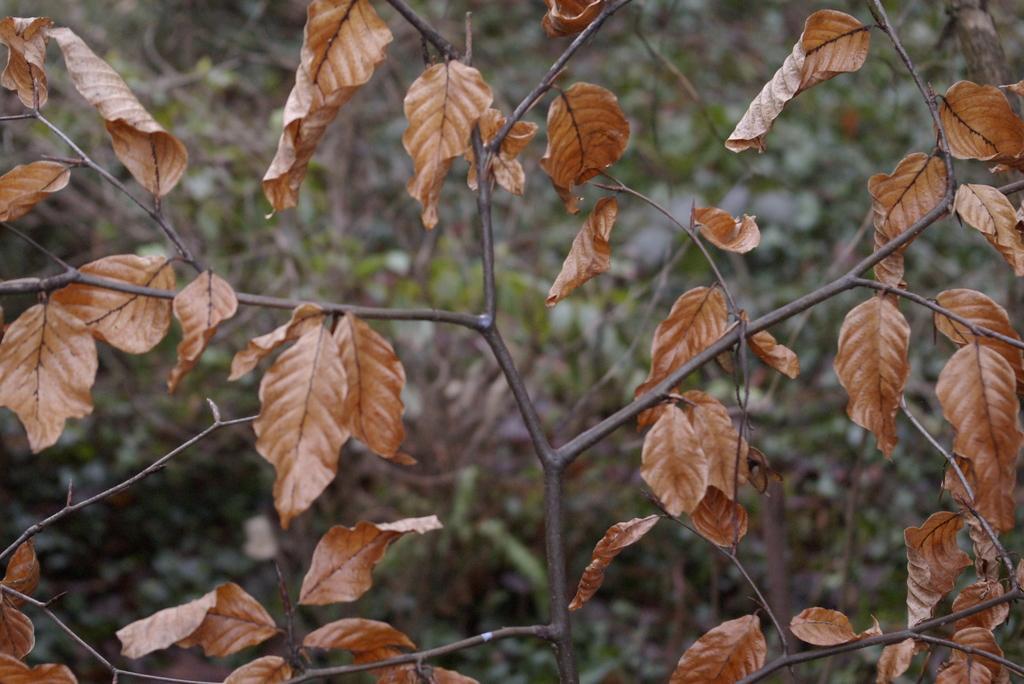Could you give a brief overview of what you see in this image? In this picture I can see few trees. 